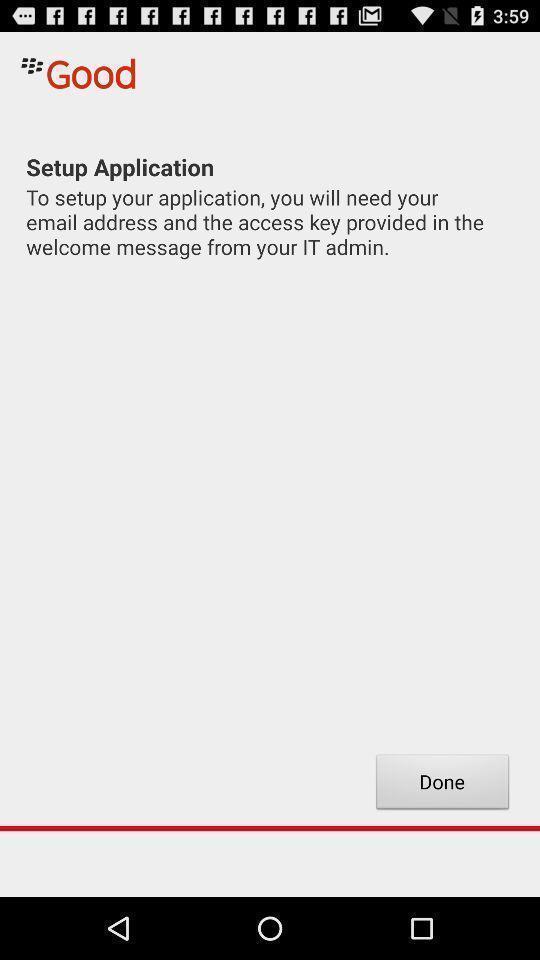What details can you identify in this image? Set up page. 